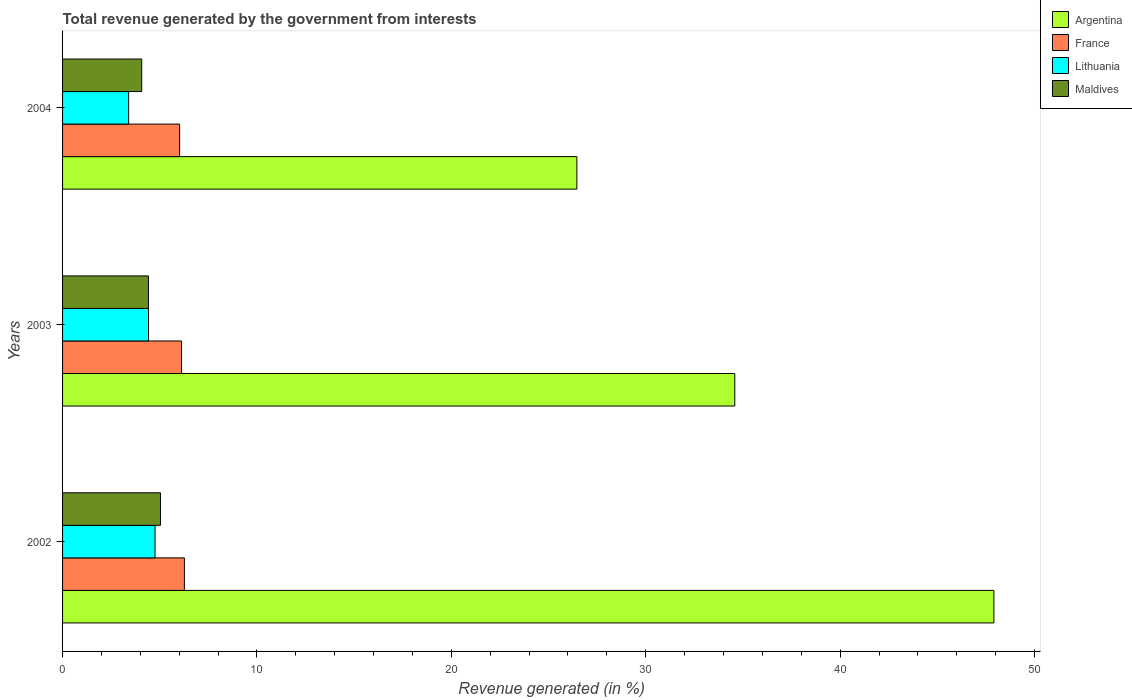How many groups of bars are there?
Provide a short and direct response. 3. What is the label of the 2nd group of bars from the top?
Keep it short and to the point. 2003. What is the total revenue generated in Lithuania in 2004?
Keep it short and to the point. 3.4. Across all years, what is the maximum total revenue generated in Lithuania?
Provide a short and direct response. 4.76. Across all years, what is the minimum total revenue generated in Maldives?
Make the answer very short. 4.07. In which year was the total revenue generated in France maximum?
Make the answer very short. 2002. What is the total total revenue generated in Maldives in the graph?
Ensure brevity in your answer.  13.53. What is the difference between the total revenue generated in Lithuania in 2003 and that in 2004?
Your answer should be very brief. 1.02. What is the difference between the total revenue generated in Maldives in 2003 and the total revenue generated in Argentina in 2002?
Make the answer very short. -43.49. What is the average total revenue generated in Argentina per year?
Give a very brief answer. 36.32. In the year 2004, what is the difference between the total revenue generated in Lithuania and total revenue generated in Maldives?
Your response must be concise. -0.67. In how many years, is the total revenue generated in Lithuania greater than 24 %?
Provide a short and direct response. 0. What is the ratio of the total revenue generated in Maldives in 2002 to that in 2003?
Your response must be concise. 1.14. Is the total revenue generated in Lithuania in 2002 less than that in 2004?
Provide a short and direct response. No. Is the difference between the total revenue generated in Lithuania in 2003 and 2004 greater than the difference between the total revenue generated in Maldives in 2003 and 2004?
Provide a short and direct response. Yes. What is the difference between the highest and the second highest total revenue generated in Lithuania?
Provide a short and direct response. 0.33. What is the difference between the highest and the lowest total revenue generated in Lithuania?
Give a very brief answer. 1.36. In how many years, is the total revenue generated in Argentina greater than the average total revenue generated in Argentina taken over all years?
Offer a very short reply. 1. What does the 2nd bar from the bottom in 2003 represents?
Provide a succinct answer. France. Are the values on the major ticks of X-axis written in scientific E-notation?
Your response must be concise. No. Does the graph contain any zero values?
Give a very brief answer. No. Where does the legend appear in the graph?
Offer a very short reply. Top right. What is the title of the graph?
Ensure brevity in your answer.  Total revenue generated by the government from interests. What is the label or title of the X-axis?
Provide a succinct answer. Revenue generated (in %). What is the label or title of the Y-axis?
Offer a very short reply. Years. What is the Revenue generated (in %) of Argentina in 2002?
Your response must be concise. 47.91. What is the Revenue generated (in %) in France in 2002?
Give a very brief answer. 6.27. What is the Revenue generated (in %) in Lithuania in 2002?
Make the answer very short. 4.76. What is the Revenue generated (in %) of Maldives in 2002?
Offer a very short reply. 5.04. What is the Revenue generated (in %) in Argentina in 2003?
Your answer should be compact. 34.58. What is the Revenue generated (in %) in France in 2003?
Offer a very short reply. 6.12. What is the Revenue generated (in %) in Lithuania in 2003?
Your response must be concise. 4.42. What is the Revenue generated (in %) in Maldives in 2003?
Offer a terse response. 4.42. What is the Revenue generated (in %) of Argentina in 2004?
Provide a short and direct response. 26.46. What is the Revenue generated (in %) in France in 2004?
Your answer should be compact. 6.02. What is the Revenue generated (in %) in Lithuania in 2004?
Your answer should be very brief. 3.4. What is the Revenue generated (in %) of Maldives in 2004?
Keep it short and to the point. 4.07. Across all years, what is the maximum Revenue generated (in %) of Argentina?
Give a very brief answer. 47.91. Across all years, what is the maximum Revenue generated (in %) of France?
Your response must be concise. 6.27. Across all years, what is the maximum Revenue generated (in %) of Lithuania?
Offer a very short reply. 4.76. Across all years, what is the maximum Revenue generated (in %) of Maldives?
Provide a short and direct response. 5.04. Across all years, what is the minimum Revenue generated (in %) of Argentina?
Your answer should be very brief. 26.46. Across all years, what is the minimum Revenue generated (in %) in France?
Make the answer very short. 6.02. Across all years, what is the minimum Revenue generated (in %) in Lithuania?
Your answer should be very brief. 3.4. Across all years, what is the minimum Revenue generated (in %) in Maldives?
Your answer should be very brief. 4.07. What is the total Revenue generated (in %) in Argentina in the graph?
Ensure brevity in your answer.  108.95. What is the total Revenue generated (in %) in France in the graph?
Your answer should be compact. 18.41. What is the total Revenue generated (in %) in Lithuania in the graph?
Provide a short and direct response. 12.58. What is the total Revenue generated (in %) in Maldives in the graph?
Ensure brevity in your answer.  13.53. What is the difference between the Revenue generated (in %) of Argentina in 2002 and that in 2003?
Give a very brief answer. 13.33. What is the difference between the Revenue generated (in %) in France in 2002 and that in 2003?
Your response must be concise. 0.15. What is the difference between the Revenue generated (in %) in Lithuania in 2002 and that in 2003?
Give a very brief answer. 0.33. What is the difference between the Revenue generated (in %) of Maldives in 2002 and that in 2003?
Provide a succinct answer. 0.62. What is the difference between the Revenue generated (in %) of Argentina in 2002 and that in 2004?
Give a very brief answer. 21.45. What is the difference between the Revenue generated (in %) in France in 2002 and that in 2004?
Give a very brief answer. 0.24. What is the difference between the Revenue generated (in %) in Lithuania in 2002 and that in 2004?
Give a very brief answer. 1.36. What is the difference between the Revenue generated (in %) of Maldives in 2002 and that in 2004?
Keep it short and to the point. 0.96. What is the difference between the Revenue generated (in %) of Argentina in 2003 and that in 2004?
Provide a short and direct response. 8.12. What is the difference between the Revenue generated (in %) of France in 2003 and that in 2004?
Keep it short and to the point. 0.1. What is the difference between the Revenue generated (in %) of Lithuania in 2003 and that in 2004?
Give a very brief answer. 1.02. What is the difference between the Revenue generated (in %) in Maldives in 2003 and that in 2004?
Your answer should be very brief. 0.35. What is the difference between the Revenue generated (in %) in Argentina in 2002 and the Revenue generated (in %) in France in 2003?
Your answer should be compact. 41.79. What is the difference between the Revenue generated (in %) in Argentina in 2002 and the Revenue generated (in %) in Lithuania in 2003?
Ensure brevity in your answer.  43.49. What is the difference between the Revenue generated (in %) in Argentina in 2002 and the Revenue generated (in %) in Maldives in 2003?
Offer a very short reply. 43.49. What is the difference between the Revenue generated (in %) of France in 2002 and the Revenue generated (in %) of Lithuania in 2003?
Make the answer very short. 1.84. What is the difference between the Revenue generated (in %) in France in 2002 and the Revenue generated (in %) in Maldives in 2003?
Offer a very short reply. 1.85. What is the difference between the Revenue generated (in %) in Lithuania in 2002 and the Revenue generated (in %) in Maldives in 2003?
Make the answer very short. 0.34. What is the difference between the Revenue generated (in %) in Argentina in 2002 and the Revenue generated (in %) in France in 2004?
Make the answer very short. 41.89. What is the difference between the Revenue generated (in %) in Argentina in 2002 and the Revenue generated (in %) in Lithuania in 2004?
Ensure brevity in your answer.  44.51. What is the difference between the Revenue generated (in %) of Argentina in 2002 and the Revenue generated (in %) of Maldives in 2004?
Your answer should be compact. 43.84. What is the difference between the Revenue generated (in %) of France in 2002 and the Revenue generated (in %) of Lithuania in 2004?
Offer a very short reply. 2.87. What is the difference between the Revenue generated (in %) of France in 2002 and the Revenue generated (in %) of Maldives in 2004?
Provide a succinct answer. 2.19. What is the difference between the Revenue generated (in %) of Lithuania in 2002 and the Revenue generated (in %) of Maldives in 2004?
Your answer should be compact. 0.68. What is the difference between the Revenue generated (in %) of Argentina in 2003 and the Revenue generated (in %) of France in 2004?
Keep it short and to the point. 28.56. What is the difference between the Revenue generated (in %) in Argentina in 2003 and the Revenue generated (in %) in Lithuania in 2004?
Offer a very short reply. 31.18. What is the difference between the Revenue generated (in %) in Argentina in 2003 and the Revenue generated (in %) in Maldives in 2004?
Your response must be concise. 30.51. What is the difference between the Revenue generated (in %) in France in 2003 and the Revenue generated (in %) in Lithuania in 2004?
Offer a very short reply. 2.72. What is the difference between the Revenue generated (in %) of France in 2003 and the Revenue generated (in %) of Maldives in 2004?
Provide a short and direct response. 2.05. What is the difference between the Revenue generated (in %) of Lithuania in 2003 and the Revenue generated (in %) of Maldives in 2004?
Provide a short and direct response. 0.35. What is the average Revenue generated (in %) of Argentina per year?
Ensure brevity in your answer.  36.32. What is the average Revenue generated (in %) of France per year?
Make the answer very short. 6.14. What is the average Revenue generated (in %) of Lithuania per year?
Give a very brief answer. 4.19. What is the average Revenue generated (in %) of Maldives per year?
Keep it short and to the point. 4.51. In the year 2002, what is the difference between the Revenue generated (in %) in Argentina and Revenue generated (in %) in France?
Make the answer very short. 41.64. In the year 2002, what is the difference between the Revenue generated (in %) of Argentina and Revenue generated (in %) of Lithuania?
Give a very brief answer. 43.15. In the year 2002, what is the difference between the Revenue generated (in %) of Argentina and Revenue generated (in %) of Maldives?
Give a very brief answer. 42.87. In the year 2002, what is the difference between the Revenue generated (in %) of France and Revenue generated (in %) of Lithuania?
Your answer should be compact. 1.51. In the year 2002, what is the difference between the Revenue generated (in %) in France and Revenue generated (in %) in Maldives?
Make the answer very short. 1.23. In the year 2002, what is the difference between the Revenue generated (in %) in Lithuania and Revenue generated (in %) in Maldives?
Provide a succinct answer. -0.28. In the year 2003, what is the difference between the Revenue generated (in %) of Argentina and Revenue generated (in %) of France?
Ensure brevity in your answer.  28.46. In the year 2003, what is the difference between the Revenue generated (in %) of Argentina and Revenue generated (in %) of Lithuania?
Keep it short and to the point. 30.16. In the year 2003, what is the difference between the Revenue generated (in %) in Argentina and Revenue generated (in %) in Maldives?
Your response must be concise. 30.16. In the year 2003, what is the difference between the Revenue generated (in %) of France and Revenue generated (in %) of Lithuania?
Provide a short and direct response. 1.7. In the year 2003, what is the difference between the Revenue generated (in %) in France and Revenue generated (in %) in Maldives?
Keep it short and to the point. 1.7. In the year 2003, what is the difference between the Revenue generated (in %) in Lithuania and Revenue generated (in %) in Maldives?
Provide a succinct answer. 0. In the year 2004, what is the difference between the Revenue generated (in %) in Argentina and Revenue generated (in %) in France?
Offer a terse response. 20.44. In the year 2004, what is the difference between the Revenue generated (in %) in Argentina and Revenue generated (in %) in Lithuania?
Offer a very short reply. 23.06. In the year 2004, what is the difference between the Revenue generated (in %) in Argentina and Revenue generated (in %) in Maldives?
Keep it short and to the point. 22.39. In the year 2004, what is the difference between the Revenue generated (in %) in France and Revenue generated (in %) in Lithuania?
Keep it short and to the point. 2.62. In the year 2004, what is the difference between the Revenue generated (in %) of France and Revenue generated (in %) of Maldives?
Offer a terse response. 1.95. In the year 2004, what is the difference between the Revenue generated (in %) of Lithuania and Revenue generated (in %) of Maldives?
Provide a succinct answer. -0.67. What is the ratio of the Revenue generated (in %) in Argentina in 2002 to that in 2003?
Offer a terse response. 1.39. What is the ratio of the Revenue generated (in %) of France in 2002 to that in 2003?
Make the answer very short. 1.02. What is the ratio of the Revenue generated (in %) of Lithuania in 2002 to that in 2003?
Offer a terse response. 1.08. What is the ratio of the Revenue generated (in %) of Maldives in 2002 to that in 2003?
Your answer should be compact. 1.14. What is the ratio of the Revenue generated (in %) of Argentina in 2002 to that in 2004?
Your answer should be very brief. 1.81. What is the ratio of the Revenue generated (in %) of France in 2002 to that in 2004?
Your response must be concise. 1.04. What is the ratio of the Revenue generated (in %) of Lithuania in 2002 to that in 2004?
Your answer should be compact. 1.4. What is the ratio of the Revenue generated (in %) in Maldives in 2002 to that in 2004?
Make the answer very short. 1.24. What is the ratio of the Revenue generated (in %) in Argentina in 2003 to that in 2004?
Your answer should be very brief. 1.31. What is the ratio of the Revenue generated (in %) in France in 2003 to that in 2004?
Give a very brief answer. 1.02. What is the ratio of the Revenue generated (in %) in Lithuania in 2003 to that in 2004?
Offer a terse response. 1.3. What is the ratio of the Revenue generated (in %) in Maldives in 2003 to that in 2004?
Offer a terse response. 1.08. What is the difference between the highest and the second highest Revenue generated (in %) of Argentina?
Your answer should be compact. 13.33. What is the difference between the highest and the second highest Revenue generated (in %) of France?
Your response must be concise. 0.15. What is the difference between the highest and the second highest Revenue generated (in %) in Lithuania?
Offer a terse response. 0.33. What is the difference between the highest and the second highest Revenue generated (in %) in Maldives?
Give a very brief answer. 0.62. What is the difference between the highest and the lowest Revenue generated (in %) of Argentina?
Give a very brief answer. 21.45. What is the difference between the highest and the lowest Revenue generated (in %) in France?
Provide a succinct answer. 0.24. What is the difference between the highest and the lowest Revenue generated (in %) in Lithuania?
Your answer should be very brief. 1.36. What is the difference between the highest and the lowest Revenue generated (in %) in Maldives?
Provide a succinct answer. 0.96. 